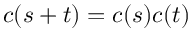<formula> <loc_0><loc_0><loc_500><loc_500>c ( s + t ) = c ( s ) c ( t )</formula> 